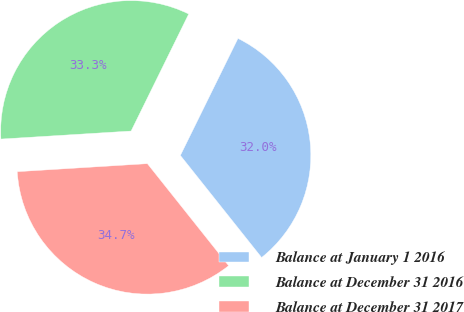Convert chart to OTSL. <chart><loc_0><loc_0><loc_500><loc_500><pie_chart><fcel>Balance at January 1 2016<fcel>Balance at December 31 2016<fcel>Balance at December 31 2017<nl><fcel>32.02%<fcel>33.26%<fcel>34.72%<nl></chart> 